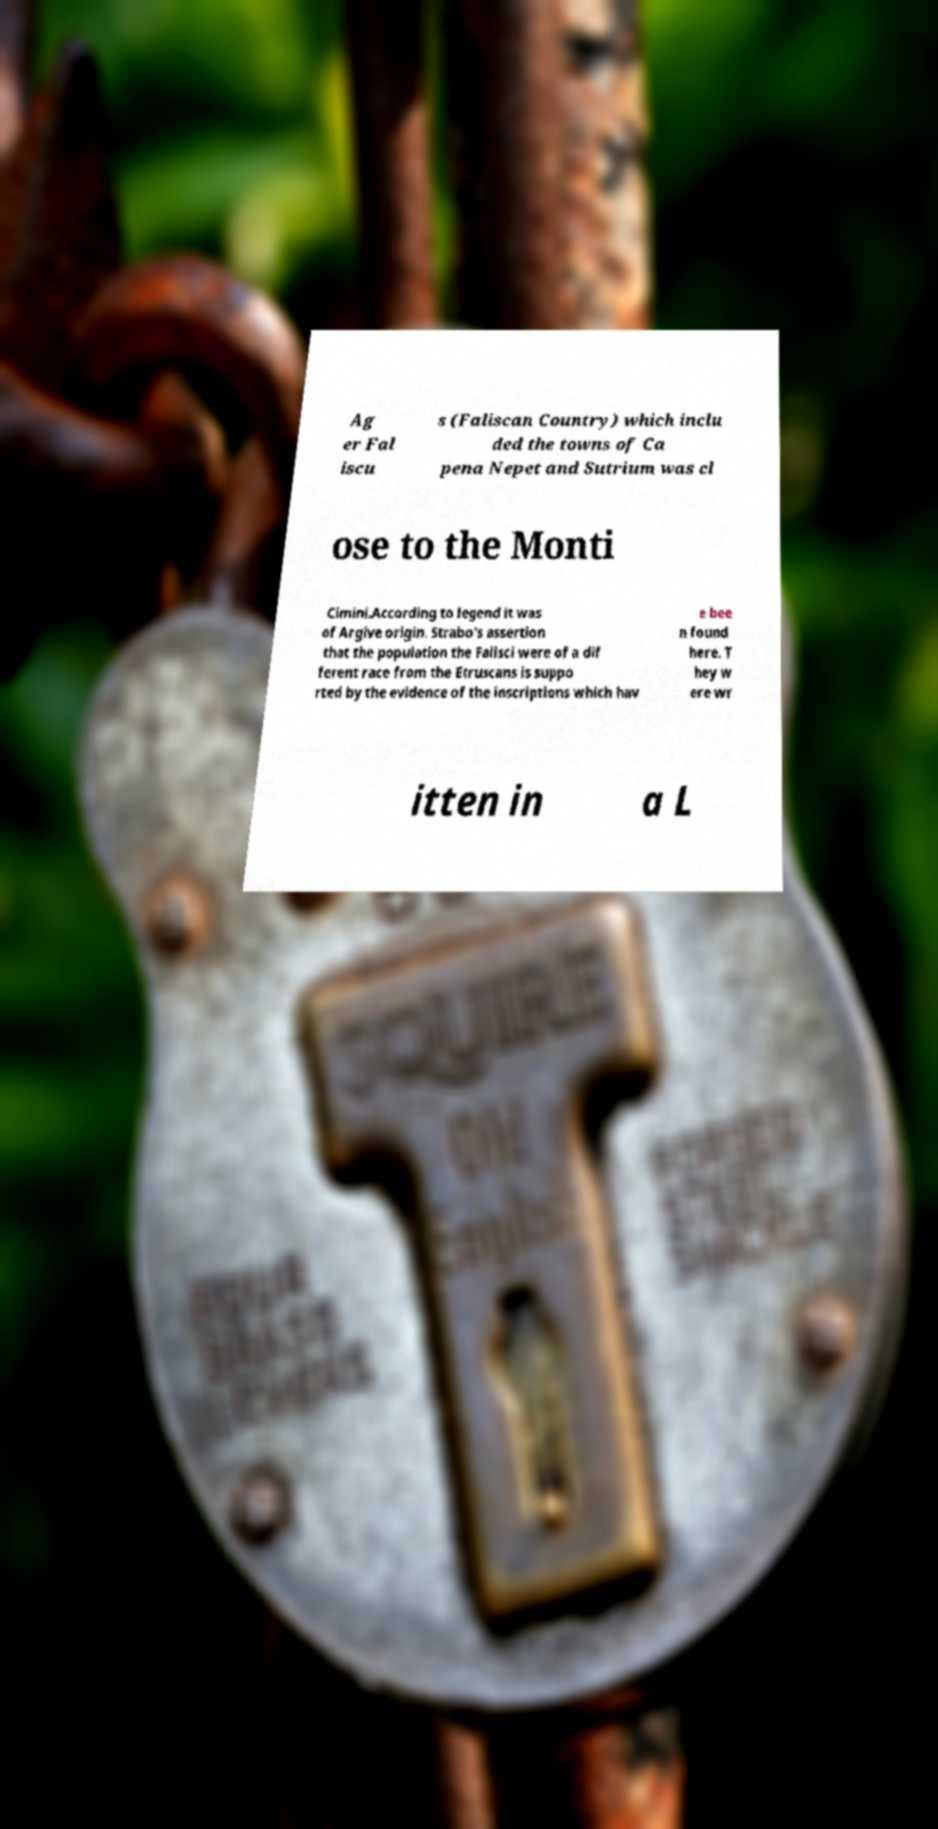Can you accurately transcribe the text from the provided image for me? Ag er Fal iscu s (Faliscan Country) which inclu ded the towns of Ca pena Nepet and Sutrium was cl ose to the Monti Cimini.According to legend it was of Argive origin. Strabo's assertion that the population the Falisci were of a dif ferent race from the Etruscans is suppo rted by the evidence of the inscriptions which hav e bee n found here. T hey w ere wr itten in a L 